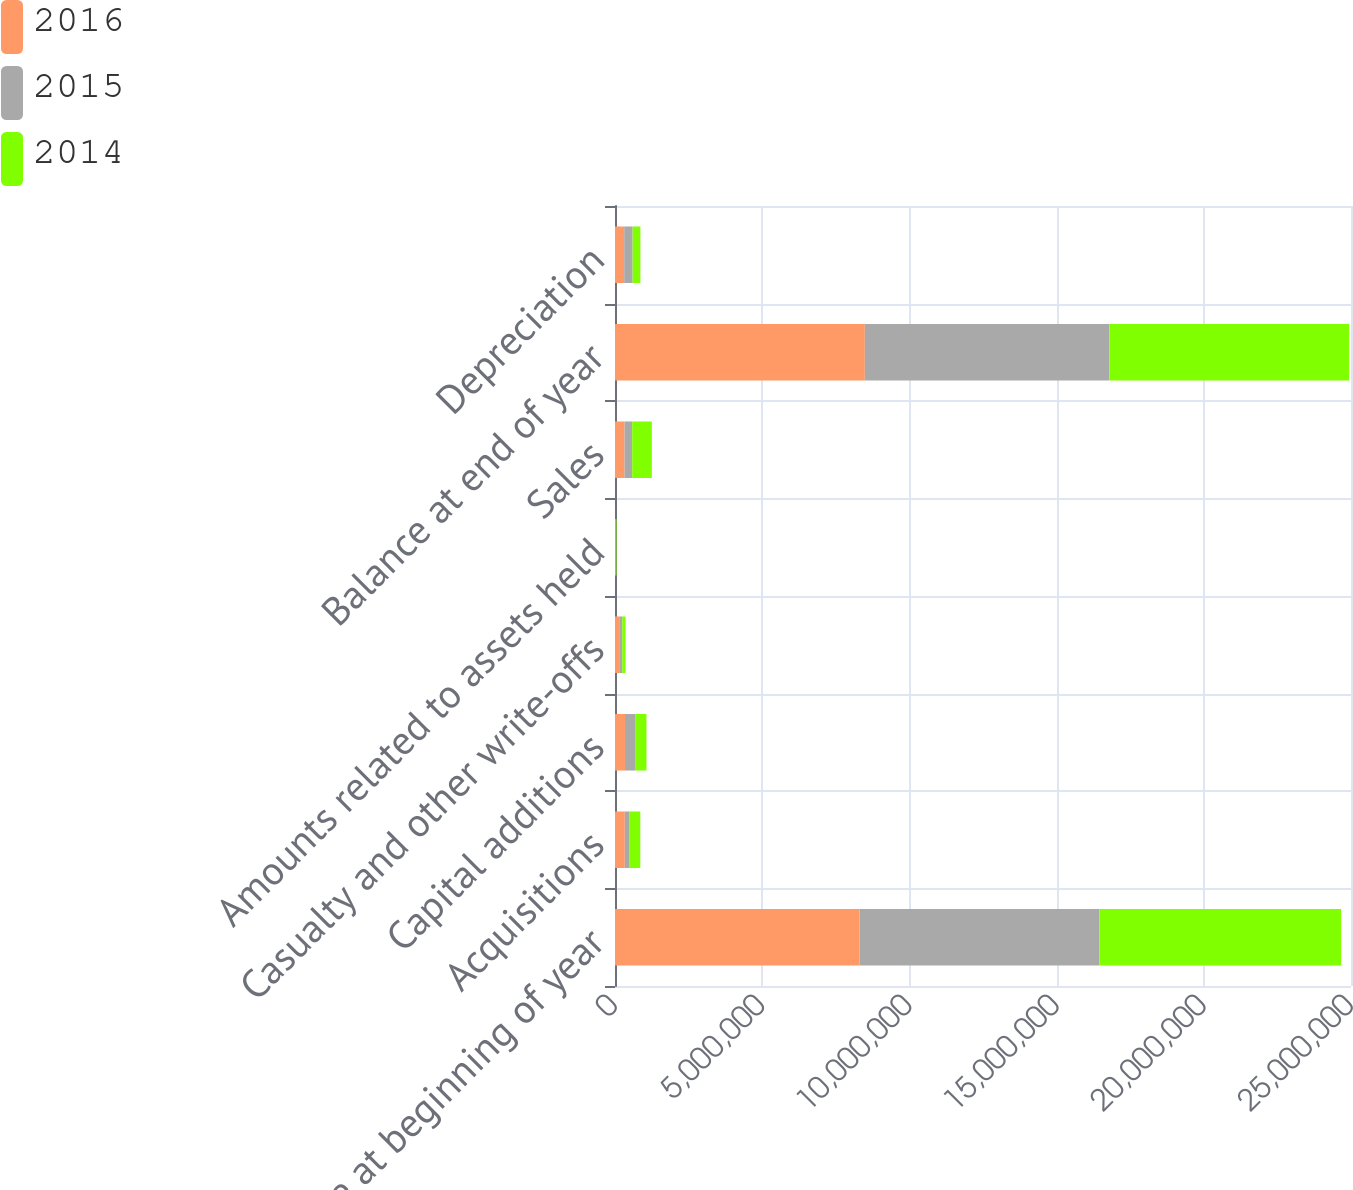Convert chart. <chart><loc_0><loc_0><loc_500><loc_500><stacked_bar_chart><ecel><fcel>Balance at beginning of year<fcel>Acquisitions<fcel>Capital additions<fcel>Casualty and other write-offs<fcel>Amounts related to assets held<fcel>Sales<fcel>Balance at end of year<fcel>Depreciation<nl><fcel>2016<fcel>8.30748e+06<fcel>333174<fcel>338606<fcel>166703<fcel>2801<fcel>323593<fcel>8.48617e+06<fcel>312365<nl><fcel>2015<fcel>8.14496e+06<fcel>147077<fcel>362948<fcel>79561<fcel>7036<fcel>260903<fcel>8.30748e+06<fcel>285514<nl><fcel>2014<fcel>8.21408e+06<fcel>379187<fcel>367454<fcel>111068<fcel>38744<fcel>665952<fcel>8.14496e+06<fcel>265060<nl></chart> 